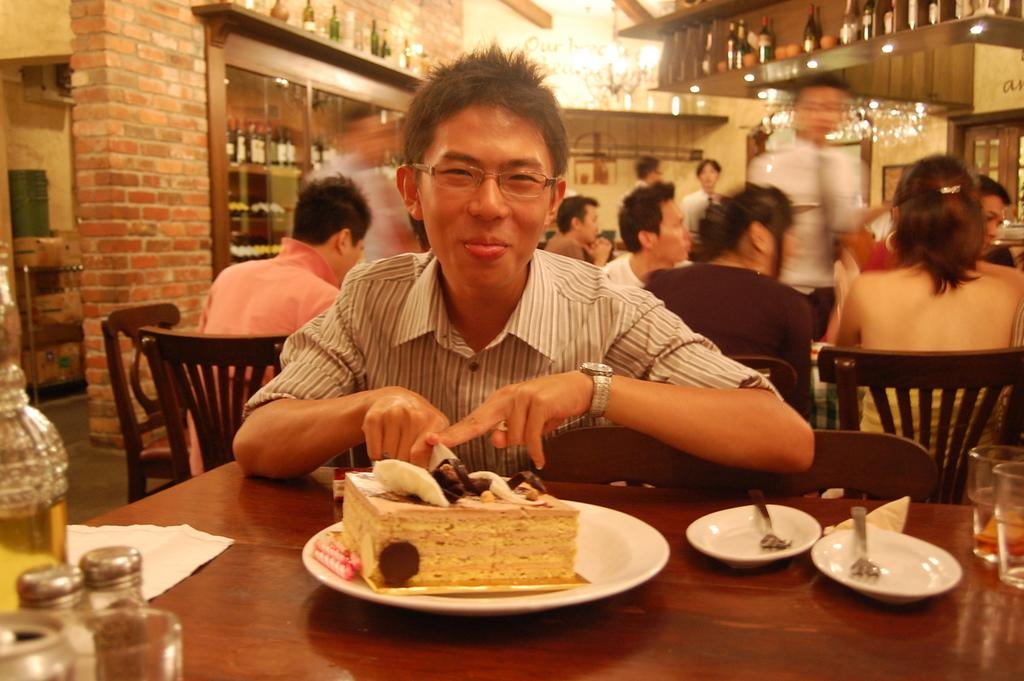What is the man in the image doing? A: The man is sitting on a chair in the image. What is in front of the man? The man is in front of a table. What is on the table? There is a cake on a plate on the table. Can you describe the setting of the image? The setting appears to be a restaurant. How many people are visible in the background? There are many people visible in the background. What time of day is it in the image, considering the presence of the sister? There is no mention of a sister in the image, and the time of day cannot be determined from the information provided. 